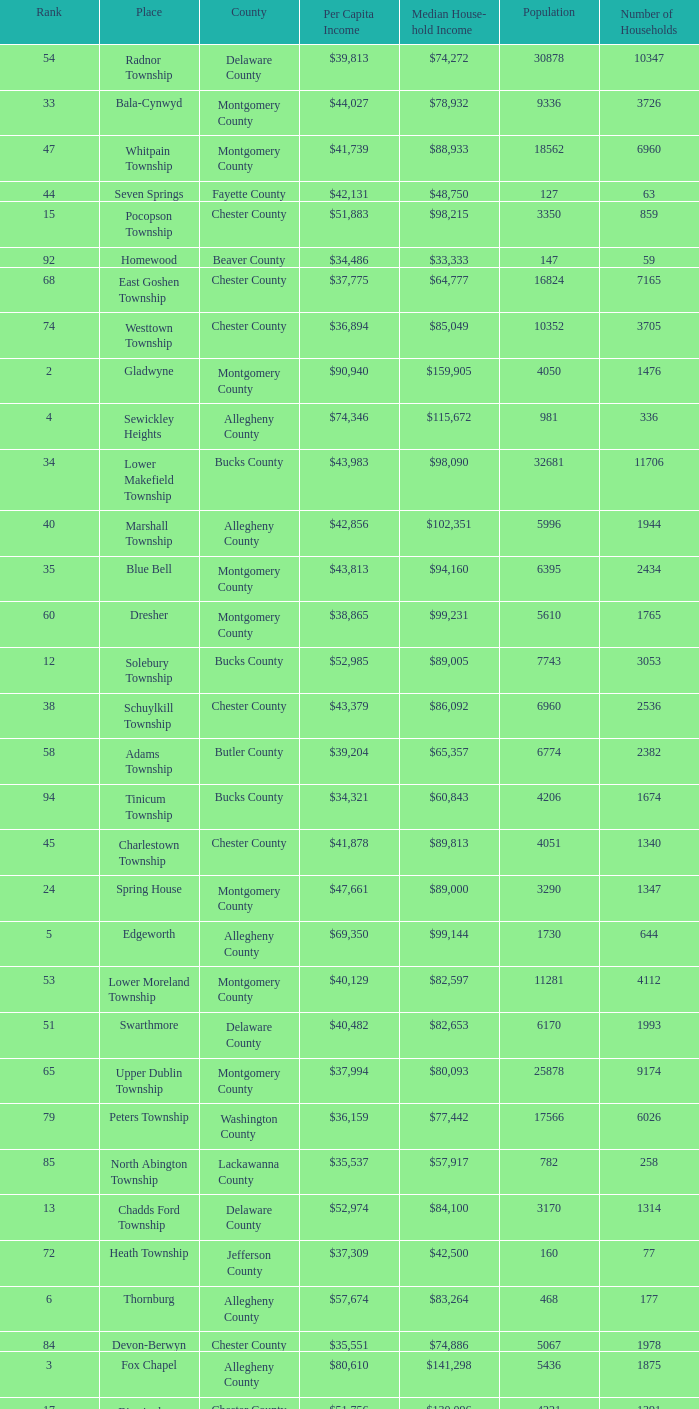Which county has a median household income of  $98,090? Bucks County. 